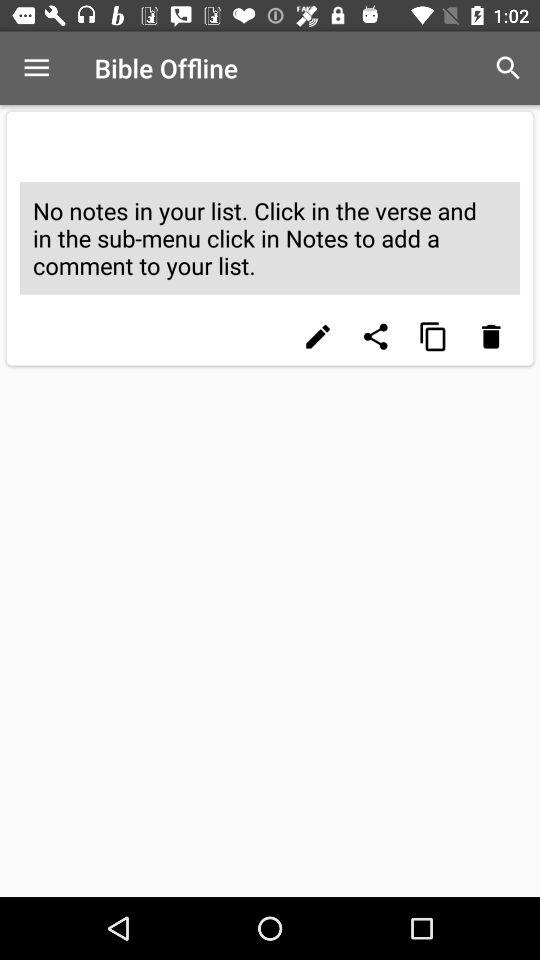What is the name of the application? The name of the application is "Bible Offline". 